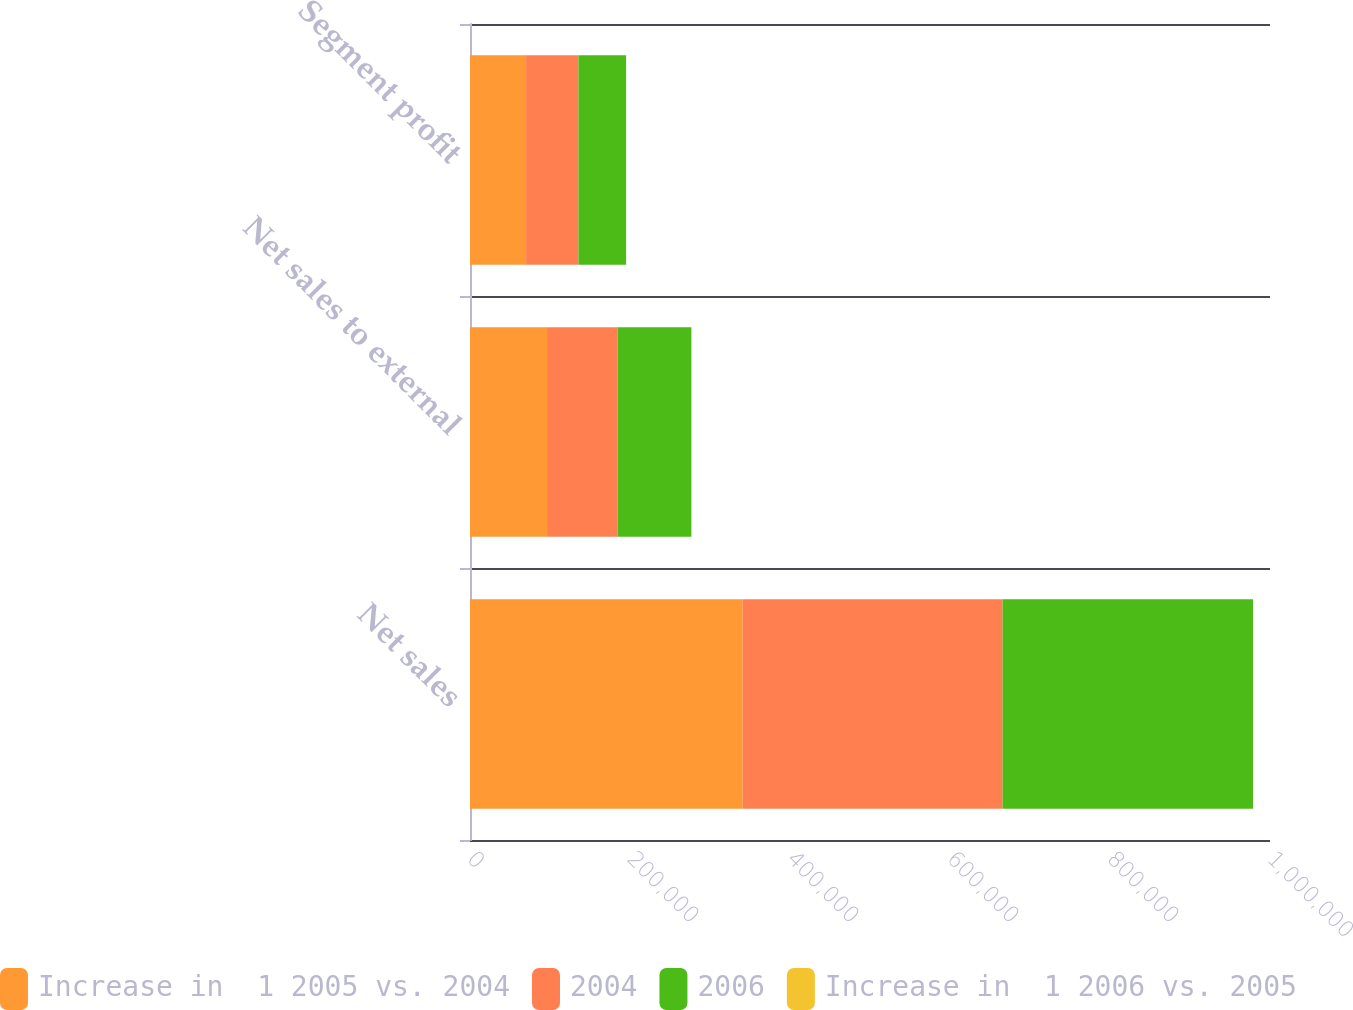<chart> <loc_0><loc_0><loc_500><loc_500><stacked_bar_chart><ecel><fcel>Net sales<fcel>Net sales to external<fcel>Segment profit<nl><fcel>Increase in  1 2005 vs. 2004<fcel>340849<fcel>96311<fcel>70083<nl><fcel>2004<fcel>324901<fcel>88138<fcel>65471<nl><fcel>2006<fcel>312992<fcel>92321<fcel>59576<nl><fcel>Increase in  1 2006 vs. 2005<fcel>5<fcel>9<fcel>7<nl></chart> 